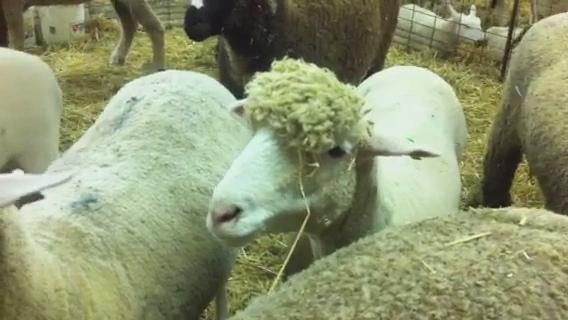What does the fur resemble? wool 